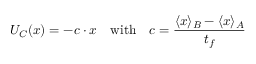<formula> <loc_0><loc_0><loc_500><loc_500>U _ { C } ( { x } ) = - { c } \cdot { x } \quad w i t h \quad c = \frac { \langle { x } \rangle _ { B } - \langle { x } \rangle _ { A } } { t _ { f } }</formula> 